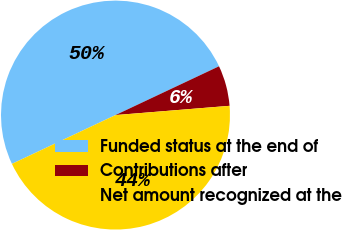<chart> <loc_0><loc_0><loc_500><loc_500><pie_chart><fcel>Funded status at the end of<fcel>Contributions after<fcel>Net amount recognized at the<nl><fcel>50.0%<fcel>5.72%<fcel>44.28%<nl></chart> 